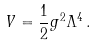Convert formula to latex. <formula><loc_0><loc_0><loc_500><loc_500>V = \frac { 1 } { 2 } g ^ { 2 } \Lambda ^ { 4 } \, .</formula> 